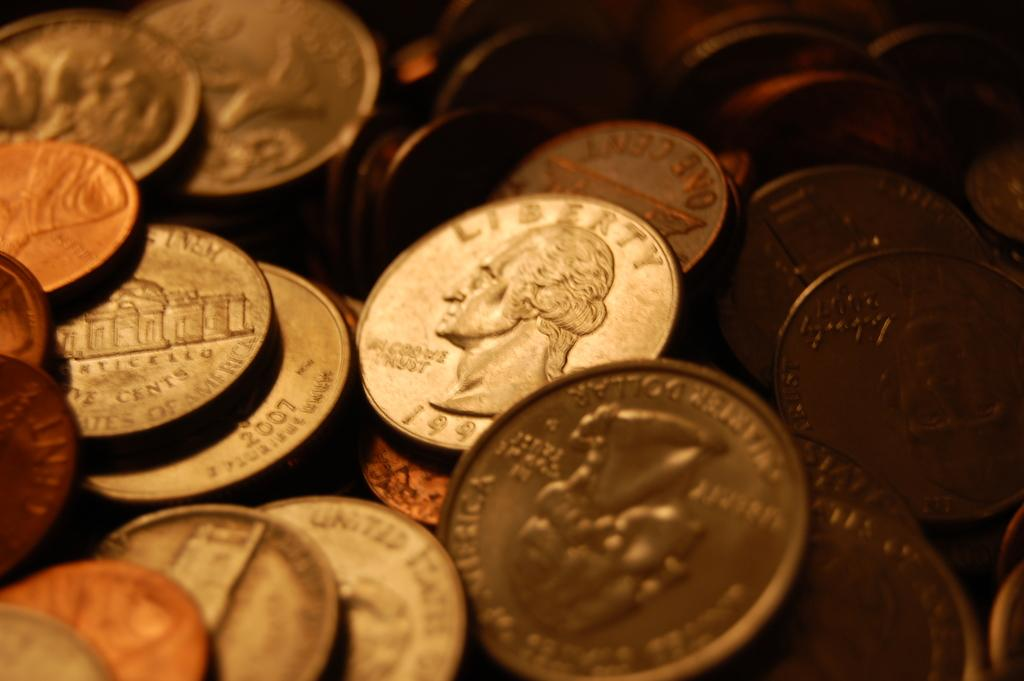<image>
Present a compact description of the photo's key features. Stacks of coins that are layed out: Quarter dated 1990 something. 